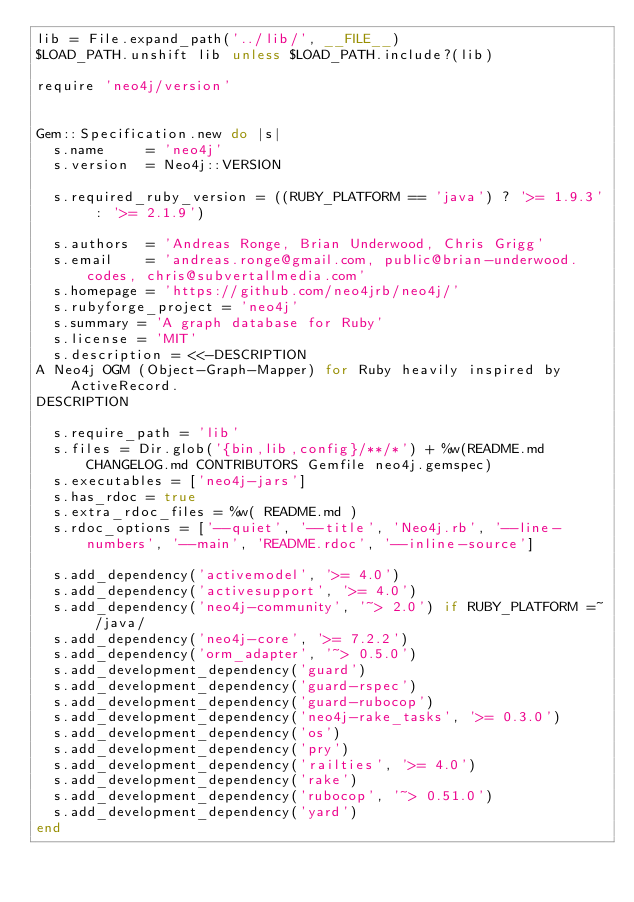<code> <loc_0><loc_0><loc_500><loc_500><_Ruby_>lib = File.expand_path('../lib/', __FILE__)
$LOAD_PATH.unshift lib unless $LOAD_PATH.include?(lib)

require 'neo4j/version'


Gem::Specification.new do |s|
  s.name     = 'neo4j'
  s.version  = Neo4j::VERSION

  s.required_ruby_version = ((RUBY_PLATFORM == 'java') ? '>= 1.9.3' : '>= 2.1.9')

  s.authors  = 'Andreas Ronge, Brian Underwood, Chris Grigg'
  s.email    = 'andreas.ronge@gmail.com, public@brian-underwood.codes, chris@subvertallmedia.com'
  s.homepage = 'https://github.com/neo4jrb/neo4j/'
  s.rubyforge_project = 'neo4j'
  s.summary = 'A graph database for Ruby'
  s.license = 'MIT'
  s.description = <<-DESCRIPTION
A Neo4j OGM (Object-Graph-Mapper) for Ruby heavily inspired by ActiveRecord.
DESCRIPTION

  s.require_path = 'lib'
  s.files = Dir.glob('{bin,lib,config}/**/*') + %w(README.md CHANGELOG.md CONTRIBUTORS Gemfile neo4j.gemspec)
  s.executables = ['neo4j-jars']
  s.has_rdoc = true
  s.extra_rdoc_files = %w( README.md )
  s.rdoc_options = ['--quiet', '--title', 'Neo4j.rb', '--line-numbers', '--main', 'README.rdoc', '--inline-source']

  s.add_dependency('activemodel', '>= 4.0')
  s.add_dependency('activesupport', '>= 4.0')
  s.add_dependency('neo4j-community', '~> 2.0') if RUBY_PLATFORM =~ /java/
  s.add_dependency('neo4j-core', '>= 7.2.2')
  s.add_dependency('orm_adapter', '~> 0.5.0')
  s.add_development_dependency('guard')
  s.add_development_dependency('guard-rspec')
  s.add_development_dependency('guard-rubocop')
  s.add_development_dependency('neo4j-rake_tasks', '>= 0.3.0')
  s.add_development_dependency('os')
  s.add_development_dependency('pry')
  s.add_development_dependency('railties', '>= 4.0')
  s.add_development_dependency('rake')
  s.add_development_dependency('rubocop', '~> 0.51.0')
  s.add_development_dependency('yard')
end
</code> 